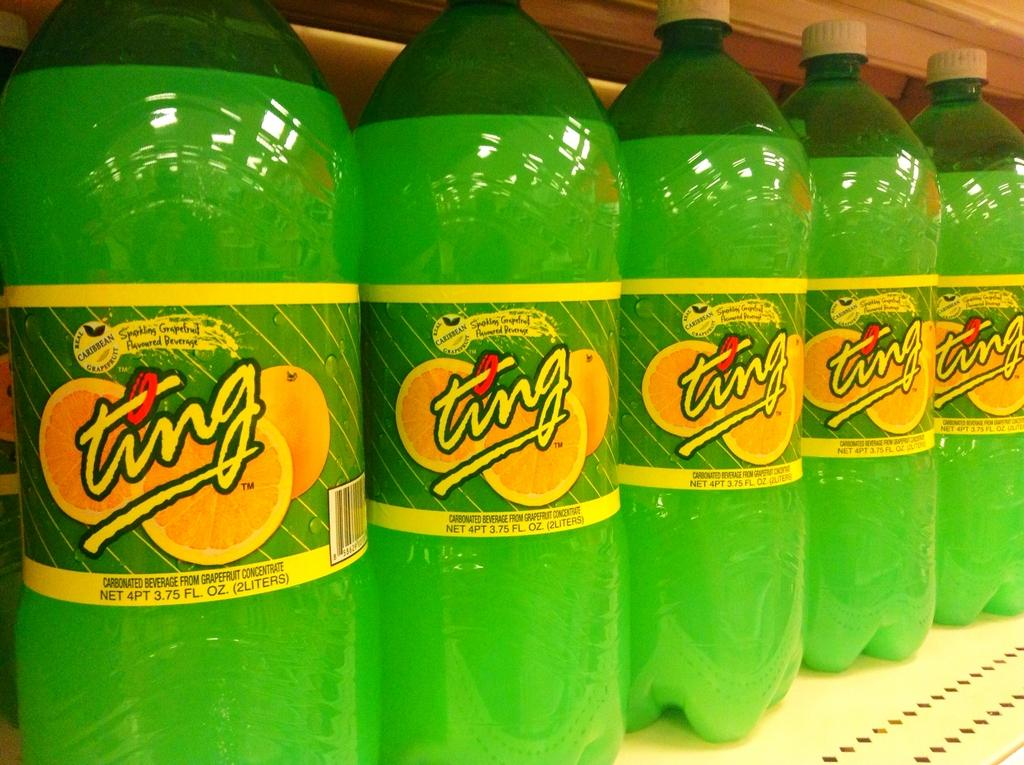<image>
Render a clear and concise summary of the photo. A white shelf full of green sodas called Ting. 